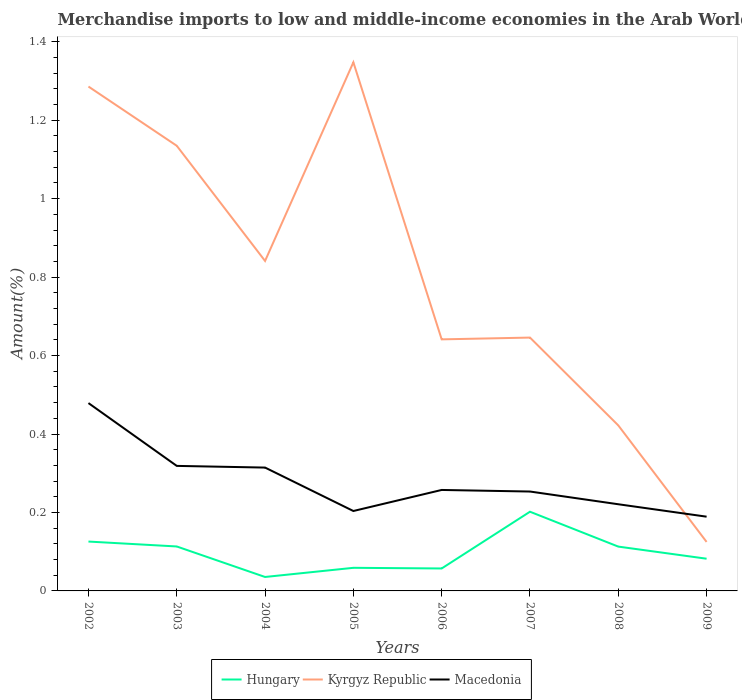How many different coloured lines are there?
Your answer should be very brief. 3. Across all years, what is the maximum percentage of amount earned from merchandise imports in Hungary?
Offer a terse response. 0.04. What is the total percentage of amount earned from merchandise imports in Hungary in the graph?
Offer a terse response. -0.02. What is the difference between the highest and the second highest percentage of amount earned from merchandise imports in Hungary?
Offer a terse response. 0.17. How many lines are there?
Your answer should be very brief. 3. What is the difference between two consecutive major ticks on the Y-axis?
Give a very brief answer. 0.2. Are the values on the major ticks of Y-axis written in scientific E-notation?
Your answer should be compact. No. How are the legend labels stacked?
Make the answer very short. Horizontal. What is the title of the graph?
Your answer should be compact. Merchandise imports to low and middle-income economies in the Arab World. Does "Belize" appear as one of the legend labels in the graph?
Your response must be concise. No. What is the label or title of the Y-axis?
Make the answer very short. Amount(%). What is the Amount(%) of Hungary in 2002?
Provide a succinct answer. 0.13. What is the Amount(%) in Kyrgyz Republic in 2002?
Your answer should be compact. 1.29. What is the Amount(%) of Macedonia in 2002?
Your response must be concise. 0.48. What is the Amount(%) of Hungary in 2003?
Give a very brief answer. 0.11. What is the Amount(%) in Kyrgyz Republic in 2003?
Your answer should be compact. 1.13. What is the Amount(%) of Macedonia in 2003?
Give a very brief answer. 0.32. What is the Amount(%) in Hungary in 2004?
Make the answer very short. 0.04. What is the Amount(%) in Kyrgyz Republic in 2004?
Provide a short and direct response. 0.84. What is the Amount(%) of Macedonia in 2004?
Your answer should be compact. 0.31. What is the Amount(%) in Hungary in 2005?
Your answer should be compact. 0.06. What is the Amount(%) of Kyrgyz Republic in 2005?
Provide a succinct answer. 1.35. What is the Amount(%) in Macedonia in 2005?
Provide a succinct answer. 0.2. What is the Amount(%) of Hungary in 2006?
Your response must be concise. 0.06. What is the Amount(%) in Kyrgyz Republic in 2006?
Your answer should be compact. 0.64. What is the Amount(%) in Macedonia in 2006?
Your answer should be very brief. 0.26. What is the Amount(%) in Hungary in 2007?
Your answer should be very brief. 0.2. What is the Amount(%) in Kyrgyz Republic in 2007?
Make the answer very short. 0.65. What is the Amount(%) in Macedonia in 2007?
Make the answer very short. 0.25. What is the Amount(%) in Hungary in 2008?
Your response must be concise. 0.11. What is the Amount(%) in Kyrgyz Republic in 2008?
Your response must be concise. 0.42. What is the Amount(%) of Macedonia in 2008?
Provide a succinct answer. 0.22. What is the Amount(%) in Hungary in 2009?
Your response must be concise. 0.08. What is the Amount(%) of Kyrgyz Republic in 2009?
Offer a very short reply. 0.12. What is the Amount(%) in Macedonia in 2009?
Offer a terse response. 0.19. Across all years, what is the maximum Amount(%) in Hungary?
Give a very brief answer. 0.2. Across all years, what is the maximum Amount(%) in Kyrgyz Republic?
Make the answer very short. 1.35. Across all years, what is the maximum Amount(%) in Macedonia?
Provide a succinct answer. 0.48. Across all years, what is the minimum Amount(%) in Hungary?
Offer a terse response. 0.04. Across all years, what is the minimum Amount(%) in Kyrgyz Republic?
Provide a succinct answer. 0.12. Across all years, what is the minimum Amount(%) in Macedonia?
Offer a terse response. 0.19. What is the total Amount(%) of Hungary in the graph?
Give a very brief answer. 0.79. What is the total Amount(%) of Kyrgyz Republic in the graph?
Keep it short and to the point. 6.44. What is the total Amount(%) in Macedonia in the graph?
Your answer should be very brief. 2.24. What is the difference between the Amount(%) of Hungary in 2002 and that in 2003?
Your response must be concise. 0.01. What is the difference between the Amount(%) of Kyrgyz Republic in 2002 and that in 2003?
Give a very brief answer. 0.15. What is the difference between the Amount(%) of Macedonia in 2002 and that in 2003?
Your answer should be compact. 0.16. What is the difference between the Amount(%) of Hungary in 2002 and that in 2004?
Provide a short and direct response. 0.09. What is the difference between the Amount(%) of Kyrgyz Republic in 2002 and that in 2004?
Ensure brevity in your answer.  0.44. What is the difference between the Amount(%) of Macedonia in 2002 and that in 2004?
Offer a terse response. 0.16. What is the difference between the Amount(%) of Hungary in 2002 and that in 2005?
Give a very brief answer. 0.07. What is the difference between the Amount(%) of Kyrgyz Republic in 2002 and that in 2005?
Ensure brevity in your answer.  -0.06. What is the difference between the Amount(%) in Macedonia in 2002 and that in 2005?
Give a very brief answer. 0.28. What is the difference between the Amount(%) in Hungary in 2002 and that in 2006?
Your answer should be compact. 0.07. What is the difference between the Amount(%) of Kyrgyz Republic in 2002 and that in 2006?
Provide a succinct answer. 0.64. What is the difference between the Amount(%) in Macedonia in 2002 and that in 2006?
Give a very brief answer. 0.22. What is the difference between the Amount(%) in Hungary in 2002 and that in 2007?
Your response must be concise. -0.08. What is the difference between the Amount(%) in Kyrgyz Republic in 2002 and that in 2007?
Offer a terse response. 0.64. What is the difference between the Amount(%) in Macedonia in 2002 and that in 2007?
Make the answer very short. 0.23. What is the difference between the Amount(%) of Hungary in 2002 and that in 2008?
Provide a short and direct response. 0.01. What is the difference between the Amount(%) in Kyrgyz Republic in 2002 and that in 2008?
Your answer should be very brief. 0.86. What is the difference between the Amount(%) in Macedonia in 2002 and that in 2008?
Keep it short and to the point. 0.26. What is the difference between the Amount(%) of Hungary in 2002 and that in 2009?
Keep it short and to the point. 0.04. What is the difference between the Amount(%) in Kyrgyz Republic in 2002 and that in 2009?
Your answer should be compact. 1.16. What is the difference between the Amount(%) in Macedonia in 2002 and that in 2009?
Ensure brevity in your answer.  0.29. What is the difference between the Amount(%) in Hungary in 2003 and that in 2004?
Offer a very short reply. 0.08. What is the difference between the Amount(%) in Kyrgyz Republic in 2003 and that in 2004?
Offer a terse response. 0.29. What is the difference between the Amount(%) of Macedonia in 2003 and that in 2004?
Offer a very short reply. 0. What is the difference between the Amount(%) in Hungary in 2003 and that in 2005?
Keep it short and to the point. 0.05. What is the difference between the Amount(%) in Kyrgyz Republic in 2003 and that in 2005?
Ensure brevity in your answer.  -0.21. What is the difference between the Amount(%) in Macedonia in 2003 and that in 2005?
Give a very brief answer. 0.12. What is the difference between the Amount(%) of Hungary in 2003 and that in 2006?
Give a very brief answer. 0.06. What is the difference between the Amount(%) in Kyrgyz Republic in 2003 and that in 2006?
Give a very brief answer. 0.49. What is the difference between the Amount(%) of Macedonia in 2003 and that in 2006?
Your answer should be compact. 0.06. What is the difference between the Amount(%) of Hungary in 2003 and that in 2007?
Your response must be concise. -0.09. What is the difference between the Amount(%) of Kyrgyz Republic in 2003 and that in 2007?
Offer a terse response. 0.49. What is the difference between the Amount(%) in Macedonia in 2003 and that in 2007?
Keep it short and to the point. 0.07. What is the difference between the Amount(%) in Kyrgyz Republic in 2003 and that in 2008?
Offer a very short reply. 0.71. What is the difference between the Amount(%) of Macedonia in 2003 and that in 2008?
Give a very brief answer. 0.1. What is the difference between the Amount(%) of Hungary in 2003 and that in 2009?
Provide a succinct answer. 0.03. What is the difference between the Amount(%) in Kyrgyz Republic in 2003 and that in 2009?
Provide a succinct answer. 1.01. What is the difference between the Amount(%) of Macedonia in 2003 and that in 2009?
Give a very brief answer. 0.13. What is the difference between the Amount(%) in Hungary in 2004 and that in 2005?
Keep it short and to the point. -0.02. What is the difference between the Amount(%) in Kyrgyz Republic in 2004 and that in 2005?
Keep it short and to the point. -0.51. What is the difference between the Amount(%) in Macedonia in 2004 and that in 2005?
Give a very brief answer. 0.11. What is the difference between the Amount(%) in Hungary in 2004 and that in 2006?
Your response must be concise. -0.02. What is the difference between the Amount(%) in Kyrgyz Republic in 2004 and that in 2006?
Your answer should be compact. 0.2. What is the difference between the Amount(%) of Macedonia in 2004 and that in 2006?
Keep it short and to the point. 0.06. What is the difference between the Amount(%) in Hungary in 2004 and that in 2007?
Offer a terse response. -0.17. What is the difference between the Amount(%) of Kyrgyz Republic in 2004 and that in 2007?
Your answer should be very brief. 0.2. What is the difference between the Amount(%) of Macedonia in 2004 and that in 2007?
Give a very brief answer. 0.06. What is the difference between the Amount(%) in Hungary in 2004 and that in 2008?
Provide a short and direct response. -0.08. What is the difference between the Amount(%) in Kyrgyz Republic in 2004 and that in 2008?
Your response must be concise. 0.42. What is the difference between the Amount(%) in Macedonia in 2004 and that in 2008?
Your answer should be compact. 0.09. What is the difference between the Amount(%) of Hungary in 2004 and that in 2009?
Give a very brief answer. -0.05. What is the difference between the Amount(%) in Kyrgyz Republic in 2004 and that in 2009?
Your answer should be compact. 0.72. What is the difference between the Amount(%) of Macedonia in 2004 and that in 2009?
Your answer should be very brief. 0.13. What is the difference between the Amount(%) in Hungary in 2005 and that in 2006?
Your answer should be very brief. 0. What is the difference between the Amount(%) in Kyrgyz Republic in 2005 and that in 2006?
Make the answer very short. 0.71. What is the difference between the Amount(%) of Macedonia in 2005 and that in 2006?
Offer a terse response. -0.05. What is the difference between the Amount(%) in Hungary in 2005 and that in 2007?
Offer a terse response. -0.14. What is the difference between the Amount(%) in Kyrgyz Republic in 2005 and that in 2007?
Make the answer very short. 0.7. What is the difference between the Amount(%) in Macedonia in 2005 and that in 2007?
Your response must be concise. -0.05. What is the difference between the Amount(%) in Hungary in 2005 and that in 2008?
Your response must be concise. -0.05. What is the difference between the Amount(%) in Kyrgyz Republic in 2005 and that in 2008?
Your answer should be very brief. 0.93. What is the difference between the Amount(%) of Macedonia in 2005 and that in 2008?
Ensure brevity in your answer.  -0.02. What is the difference between the Amount(%) of Hungary in 2005 and that in 2009?
Offer a very short reply. -0.02. What is the difference between the Amount(%) of Kyrgyz Republic in 2005 and that in 2009?
Your response must be concise. 1.22. What is the difference between the Amount(%) of Macedonia in 2005 and that in 2009?
Ensure brevity in your answer.  0.01. What is the difference between the Amount(%) of Hungary in 2006 and that in 2007?
Give a very brief answer. -0.14. What is the difference between the Amount(%) in Kyrgyz Republic in 2006 and that in 2007?
Your response must be concise. -0. What is the difference between the Amount(%) of Macedonia in 2006 and that in 2007?
Your response must be concise. 0. What is the difference between the Amount(%) in Hungary in 2006 and that in 2008?
Offer a very short reply. -0.06. What is the difference between the Amount(%) in Kyrgyz Republic in 2006 and that in 2008?
Offer a terse response. 0.22. What is the difference between the Amount(%) of Macedonia in 2006 and that in 2008?
Your answer should be very brief. 0.04. What is the difference between the Amount(%) in Hungary in 2006 and that in 2009?
Your answer should be very brief. -0.02. What is the difference between the Amount(%) of Kyrgyz Republic in 2006 and that in 2009?
Make the answer very short. 0.52. What is the difference between the Amount(%) in Macedonia in 2006 and that in 2009?
Make the answer very short. 0.07. What is the difference between the Amount(%) in Hungary in 2007 and that in 2008?
Ensure brevity in your answer.  0.09. What is the difference between the Amount(%) in Kyrgyz Republic in 2007 and that in 2008?
Make the answer very short. 0.22. What is the difference between the Amount(%) in Macedonia in 2007 and that in 2008?
Give a very brief answer. 0.03. What is the difference between the Amount(%) of Hungary in 2007 and that in 2009?
Give a very brief answer. 0.12. What is the difference between the Amount(%) in Kyrgyz Republic in 2007 and that in 2009?
Your response must be concise. 0.52. What is the difference between the Amount(%) in Macedonia in 2007 and that in 2009?
Your answer should be very brief. 0.06. What is the difference between the Amount(%) of Hungary in 2008 and that in 2009?
Provide a short and direct response. 0.03. What is the difference between the Amount(%) in Kyrgyz Republic in 2008 and that in 2009?
Make the answer very short. 0.3. What is the difference between the Amount(%) in Macedonia in 2008 and that in 2009?
Your response must be concise. 0.03. What is the difference between the Amount(%) of Hungary in 2002 and the Amount(%) of Kyrgyz Republic in 2003?
Your response must be concise. -1.01. What is the difference between the Amount(%) in Hungary in 2002 and the Amount(%) in Macedonia in 2003?
Make the answer very short. -0.19. What is the difference between the Amount(%) in Kyrgyz Republic in 2002 and the Amount(%) in Macedonia in 2003?
Give a very brief answer. 0.97. What is the difference between the Amount(%) in Hungary in 2002 and the Amount(%) in Kyrgyz Republic in 2004?
Keep it short and to the point. -0.72. What is the difference between the Amount(%) in Hungary in 2002 and the Amount(%) in Macedonia in 2004?
Make the answer very short. -0.19. What is the difference between the Amount(%) in Kyrgyz Republic in 2002 and the Amount(%) in Macedonia in 2004?
Give a very brief answer. 0.97. What is the difference between the Amount(%) in Hungary in 2002 and the Amount(%) in Kyrgyz Republic in 2005?
Ensure brevity in your answer.  -1.22. What is the difference between the Amount(%) of Hungary in 2002 and the Amount(%) of Macedonia in 2005?
Your answer should be compact. -0.08. What is the difference between the Amount(%) in Kyrgyz Republic in 2002 and the Amount(%) in Macedonia in 2005?
Give a very brief answer. 1.08. What is the difference between the Amount(%) in Hungary in 2002 and the Amount(%) in Kyrgyz Republic in 2006?
Your answer should be compact. -0.52. What is the difference between the Amount(%) of Hungary in 2002 and the Amount(%) of Macedonia in 2006?
Your answer should be compact. -0.13. What is the difference between the Amount(%) in Kyrgyz Republic in 2002 and the Amount(%) in Macedonia in 2006?
Offer a terse response. 1.03. What is the difference between the Amount(%) in Hungary in 2002 and the Amount(%) in Kyrgyz Republic in 2007?
Offer a terse response. -0.52. What is the difference between the Amount(%) in Hungary in 2002 and the Amount(%) in Macedonia in 2007?
Your answer should be compact. -0.13. What is the difference between the Amount(%) of Kyrgyz Republic in 2002 and the Amount(%) of Macedonia in 2007?
Give a very brief answer. 1.03. What is the difference between the Amount(%) in Hungary in 2002 and the Amount(%) in Kyrgyz Republic in 2008?
Your response must be concise. -0.3. What is the difference between the Amount(%) of Hungary in 2002 and the Amount(%) of Macedonia in 2008?
Ensure brevity in your answer.  -0.1. What is the difference between the Amount(%) in Kyrgyz Republic in 2002 and the Amount(%) in Macedonia in 2008?
Your answer should be very brief. 1.06. What is the difference between the Amount(%) of Hungary in 2002 and the Amount(%) of Kyrgyz Republic in 2009?
Offer a very short reply. 0. What is the difference between the Amount(%) of Hungary in 2002 and the Amount(%) of Macedonia in 2009?
Offer a terse response. -0.06. What is the difference between the Amount(%) of Kyrgyz Republic in 2002 and the Amount(%) of Macedonia in 2009?
Keep it short and to the point. 1.1. What is the difference between the Amount(%) in Hungary in 2003 and the Amount(%) in Kyrgyz Republic in 2004?
Offer a terse response. -0.73. What is the difference between the Amount(%) of Hungary in 2003 and the Amount(%) of Macedonia in 2004?
Your answer should be compact. -0.2. What is the difference between the Amount(%) in Kyrgyz Republic in 2003 and the Amount(%) in Macedonia in 2004?
Provide a short and direct response. 0.82. What is the difference between the Amount(%) of Hungary in 2003 and the Amount(%) of Kyrgyz Republic in 2005?
Give a very brief answer. -1.23. What is the difference between the Amount(%) of Hungary in 2003 and the Amount(%) of Macedonia in 2005?
Give a very brief answer. -0.09. What is the difference between the Amount(%) of Kyrgyz Republic in 2003 and the Amount(%) of Macedonia in 2005?
Keep it short and to the point. 0.93. What is the difference between the Amount(%) in Hungary in 2003 and the Amount(%) in Kyrgyz Republic in 2006?
Keep it short and to the point. -0.53. What is the difference between the Amount(%) of Hungary in 2003 and the Amount(%) of Macedonia in 2006?
Ensure brevity in your answer.  -0.14. What is the difference between the Amount(%) of Kyrgyz Republic in 2003 and the Amount(%) of Macedonia in 2006?
Provide a short and direct response. 0.88. What is the difference between the Amount(%) in Hungary in 2003 and the Amount(%) in Kyrgyz Republic in 2007?
Offer a very short reply. -0.53. What is the difference between the Amount(%) in Hungary in 2003 and the Amount(%) in Macedonia in 2007?
Keep it short and to the point. -0.14. What is the difference between the Amount(%) of Kyrgyz Republic in 2003 and the Amount(%) of Macedonia in 2007?
Give a very brief answer. 0.88. What is the difference between the Amount(%) of Hungary in 2003 and the Amount(%) of Kyrgyz Republic in 2008?
Provide a short and direct response. -0.31. What is the difference between the Amount(%) of Hungary in 2003 and the Amount(%) of Macedonia in 2008?
Your response must be concise. -0.11. What is the difference between the Amount(%) of Kyrgyz Republic in 2003 and the Amount(%) of Macedonia in 2008?
Provide a short and direct response. 0.91. What is the difference between the Amount(%) of Hungary in 2003 and the Amount(%) of Kyrgyz Republic in 2009?
Keep it short and to the point. -0.01. What is the difference between the Amount(%) in Hungary in 2003 and the Amount(%) in Macedonia in 2009?
Offer a very short reply. -0.08. What is the difference between the Amount(%) in Kyrgyz Republic in 2003 and the Amount(%) in Macedonia in 2009?
Make the answer very short. 0.95. What is the difference between the Amount(%) of Hungary in 2004 and the Amount(%) of Kyrgyz Republic in 2005?
Your answer should be compact. -1.31. What is the difference between the Amount(%) of Hungary in 2004 and the Amount(%) of Macedonia in 2005?
Your answer should be compact. -0.17. What is the difference between the Amount(%) of Kyrgyz Republic in 2004 and the Amount(%) of Macedonia in 2005?
Give a very brief answer. 0.64. What is the difference between the Amount(%) of Hungary in 2004 and the Amount(%) of Kyrgyz Republic in 2006?
Give a very brief answer. -0.61. What is the difference between the Amount(%) in Hungary in 2004 and the Amount(%) in Macedonia in 2006?
Offer a terse response. -0.22. What is the difference between the Amount(%) of Kyrgyz Republic in 2004 and the Amount(%) of Macedonia in 2006?
Keep it short and to the point. 0.58. What is the difference between the Amount(%) in Hungary in 2004 and the Amount(%) in Kyrgyz Republic in 2007?
Your response must be concise. -0.61. What is the difference between the Amount(%) in Hungary in 2004 and the Amount(%) in Macedonia in 2007?
Offer a very short reply. -0.22. What is the difference between the Amount(%) of Kyrgyz Republic in 2004 and the Amount(%) of Macedonia in 2007?
Offer a terse response. 0.59. What is the difference between the Amount(%) of Hungary in 2004 and the Amount(%) of Kyrgyz Republic in 2008?
Your answer should be very brief. -0.39. What is the difference between the Amount(%) of Hungary in 2004 and the Amount(%) of Macedonia in 2008?
Provide a succinct answer. -0.19. What is the difference between the Amount(%) of Kyrgyz Republic in 2004 and the Amount(%) of Macedonia in 2008?
Ensure brevity in your answer.  0.62. What is the difference between the Amount(%) in Hungary in 2004 and the Amount(%) in Kyrgyz Republic in 2009?
Provide a succinct answer. -0.09. What is the difference between the Amount(%) in Hungary in 2004 and the Amount(%) in Macedonia in 2009?
Make the answer very short. -0.15. What is the difference between the Amount(%) of Kyrgyz Republic in 2004 and the Amount(%) of Macedonia in 2009?
Give a very brief answer. 0.65. What is the difference between the Amount(%) in Hungary in 2005 and the Amount(%) in Kyrgyz Republic in 2006?
Offer a very short reply. -0.58. What is the difference between the Amount(%) of Hungary in 2005 and the Amount(%) of Macedonia in 2006?
Offer a terse response. -0.2. What is the difference between the Amount(%) in Kyrgyz Republic in 2005 and the Amount(%) in Macedonia in 2006?
Offer a very short reply. 1.09. What is the difference between the Amount(%) of Hungary in 2005 and the Amount(%) of Kyrgyz Republic in 2007?
Offer a terse response. -0.59. What is the difference between the Amount(%) of Hungary in 2005 and the Amount(%) of Macedonia in 2007?
Offer a very short reply. -0.19. What is the difference between the Amount(%) in Kyrgyz Republic in 2005 and the Amount(%) in Macedonia in 2007?
Your response must be concise. 1.09. What is the difference between the Amount(%) in Hungary in 2005 and the Amount(%) in Kyrgyz Republic in 2008?
Keep it short and to the point. -0.36. What is the difference between the Amount(%) of Hungary in 2005 and the Amount(%) of Macedonia in 2008?
Keep it short and to the point. -0.16. What is the difference between the Amount(%) of Kyrgyz Republic in 2005 and the Amount(%) of Macedonia in 2008?
Provide a succinct answer. 1.13. What is the difference between the Amount(%) of Hungary in 2005 and the Amount(%) of Kyrgyz Republic in 2009?
Give a very brief answer. -0.07. What is the difference between the Amount(%) in Hungary in 2005 and the Amount(%) in Macedonia in 2009?
Provide a succinct answer. -0.13. What is the difference between the Amount(%) in Kyrgyz Republic in 2005 and the Amount(%) in Macedonia in 2009?
Provide a succinct answer. 1.16. What is the difference between the Amount(%) of Hungary in 2006 and the Amount(%) of Kyrgyz Republic in 2007?
Your answer should be compact. -0.59. What is the difference between the Amount(%) of Hungary in 2006 and the Amount(%) of Macedonia in 2007?
Ensure brevity in your answer.  -0.2. What is the difference between the Amount(%) of Kyrgyz Republic in 2006 and the Amount(%) of Macedonia in 2007?
Provide a succinct answer. 0.39. What is the difference between the Amount(%) in Hungary in 2006 and the Amount(%) in Kyrgyz Republic in 2008?
Ensure brevity in your answer.  -0.36. What is the difference between the Amount(%) of Hungary in 2006 and the Amount(%) of Macedonia in 2008?
Your response must be concise. -0.16. What is the difference between the Amount(%) of Kyrgyz Republic in 2006 and the Amount(%) of Macedonia in 2008?
Provide a succinct answer. 0.42. What is the difference between the Amount(%) of Hungary in 2006 and the Amount(%) of Kyrgyz Republic in 2009?
Offer a very short reply. -0.07. What is the difference between the Amount(%) of Hungary in 2006 and the Amount(%) of Macedonia in 2009?
Your answer should be compact. -0.13. What is the difference between the Amount(%) of Kyrgyz Republic in 2006 and the Amount(%) of Macedonia in 2009?
Give a very brief answer. 0.45. What is the difference between the Amount(%) in Hungary in 2007 and the Amount(%) in Kyrgyz Republic in 2008?
Ensure brevity in your answer.  -0.22. What is the difference between the Amount(%) in Hungary in 2007 and the Amount(%) in Macedonia in 2008?
Your answer should be compact. -0.02. What is the difference between the Amount(%) in Kyrgyz Republic in 2007 and the Amount(%) in Macedonia in 2008?
Make the answer very short. 0.42. What is the difference between the Amount(%) of Hungary in 2007 and the Amount(%) of Kyrgyz Republic in 2009?
Give a very brief answer. 0.08. What is the difference between the Amount(%) in Hungary in 2007 and the Amount(%) in Macedonia in 2009?
Provide a short and direct response. 0.01. What is the difference between the Amount(%) in Kyrgyz Republic in 2007 and the Amount(%) in Macedonia in 2009?
Make the answer very short. 0.46. What is the difference between the Amount(%) of Hungary in 2008 and the Amount(%) of Kyrgyz Republic in 2009?
Provide a succinct answer. -0.01. What is the difference between the Amount(%) in Hungary in 2008 and the Amount(%) in Macedonia in 2009?
Provide a succinct answer. -0.08. What is the difference between the Amount(%) of Kyrgyz Republic in 2008 and the Amount(%) of Macedonia in 2009?
Give a very brief answer. 0.23. What is the average Amount(%) in Hungary per year?
Your response must be concise. 0.1. What is the average Amount(%) in Kyrgyz Republic per year?
Offer a very short reply. 0.81. What is the average Amount(%) in Macedonia per year?
Provide a succinct answer. 0.28. In the year 2002, what is the difference between the Amount(%) of Hungary and Amount(%) of Kyrgyz Republic?
Give a very brief answer. -1.16. In the year 2002, what is the difference between the Amount(%) in Hungary and Amount(%) in Macedonia?
Make the answer very short. -0.35. In the year 2002, what is the difference between the Amount(%) in Kyrgyz Republic and Amount(%) in Macedonia?
Your response must be concise. 0.81. In the year 2003, what is the difference between the Amount(%) of Hungary and Amount(%) of Kyrgyz Republic?
Give a very brief answer. -1.02. In the year 2003, what is the difference between the Amount(%) in Hungary and Amount(%) in Macedonia?
Your response must be concise. -0.21. In the year 2003, what is the difference between the Amount(%) of Kyrgyz Republic and Amount(%) of Macedonia?
Offer a terse response. 0.82. In the year 2004, what is the difference between the Amount(%) in Hungary and Amount(%) in Kyrgyz Republic?
Make the answer very short. -0.81. In the year 2004, what is the difference between the Amount(%) of Hungary and Amount(%) of Macedonia?
Keep it short and to the point. -0.28. In the year 2004, what is the difference between the Amount(%) in Kyrgyz Republic and Amount(%) in Macedonia?
Give a very brief answer. 0.53. In the year 2005, what is the difference between the Amount(%) in Hungary and Amount(%) in Kyrgyz Republic?
Offer a very short reply. -1.29. In the year 2005, what is the difference between the Amount(%) of Hungary and Amount(%) of Macedonia?
Make the answer very short. -0.14. In the year 2005, what is the difference between the Amount(%) of Kyrgyz Republic and Amount(%) of Macedonia?
Your response must be concise. 1.14. In the year 2006, what is the difference between the Amount(%) of Hungary and Amount(%) of Kyrgyz Republic?
Give a very brief answer. -0.58. In the year 2006, what is the difference between the Amount(%) in Hungary and Amount(%) in Macedonia?
Give a very brief answer. -0.2. In the year 2006, what is the difference between the Amount(%) in Kyrgyz Republic and Amount(%) in Macedonia?
Keep it short and to the point. 0.38. In the year 2007, what is the difference between the Amount(%) of Hungary and Amount(%) of Kyrgyz Republic?
Give a very brief answer. -0.44. In the year 2007, what is the difference between the Amount(%) in Hungary and Amount(%) in Macedonia?
Your response must be concise. -0.05. In the year 2007, what is the difference between the Amount(%) of Kyrgyz Republic and Amount(%) of Macedonia?
Offer a terse response. 0.39. In the year 2008, what is the difference between the Amount(%) of Hungary and Amount(%) of Kyrgyz Republic?
Your response must be concise. -0.31. In the year 2008, what is the difference between the Amount(%) of Hungary and Amount(%) of Macedonia?
Ensure brevity in your answer.  -0.11. In the year 2008, what is the difference between the Amount(%) of Kyrgyz Republic and Amount(%) of Macedonia?
Offer a very short reply. 0.2. In the year 2009, what is the difference between the Amount(%) of Hungary and Amount(%) of Kyrgyz Republic?
Offer a very short reply. -0.04. In the year 2009, what is the difference between the Amount(%) of Hungary and Amount(%) of Macedonia?
Your answer should be very brief. -0.11. In the year 2009, what is the difference between the Amount(%) of Kyrgyz Republic and Amount(%) of Macedonia?
Your response must be concise. -0.06. What is the ratio of the Amount(%) in Hungary in 2002 to that in 2003?
Keep it short and to the point. 1.11. What is the ratio of the Amount(%) of Kyrgyz Republic in 2002 to that in 2003?
Give a very brief answer. 1.13. What is the ratio of the Amount(%) in Macedonia in 2002 to that in 2003?
Make the answer very short. 1.5. What is the ratio of the Amount(%) of Hungary in 2002 to that in 2004?
Your answer should be compact. 3.54. What is the ratio of the Amount(%) of Kyrgyz Republic in 2002 to that in 2004?
Your response must be concise. 1.53. What is the ratio of the Amount(%) in Macedonia in 2002 to that in 2004?
Your answer should be compact. 1.52. What is the ratio of the Amount(%) of Hungary in 2002 to that in 2005?
Your answer should be compact. 2.14. What is the ratio of the Amount(%) in Kyrgyz Republic in 2002 to that in 2005?
Provide a short and direct response. 0.95. What is the ratio of the Amount(%) in Macedonia in 2002 to that in 2005?
Your answer should be compact. 2.35. What is the ratio of the Amount(%) in Hungary in 2002 to that in 2006?
Provide a short and direct response. 2.2. What is the ratio of the Amount(%) of Kyrgyz Republic in 2002 to that in 2006?
Offer a terse response. 2. What is the ratio of the Amount(%) in Macedonia in 2002 to that in 2006?
Keep it short and to the point. 1.86. What is the ratio of the Amount(%) of Hungary in 2002 to that in 2007?
Give a very brief answer. 0.62. What is the ratio of the Amount(%) of Kyrgyz Republic in 2002 to that in 2007?
Give a very brief answer. 1.99. What is the ratio of the Amount(%) of Macedonia in 2002 to that in 2007?
Your answer should be compact. 1.89. What is the ratio of the Amount(%) of Hungary in 2002 to that in 2008?
Make the answer very short. 1.11. What is the ratio of the Amount(%) of Kyrgyz Republic in 2002 to that in 2008?
Provide a succinct answer. 3.05. What is the ratio of the Amount(%) of Macedonia in 2002 to that in 2008?
Give a very brief answer. 2.17. What is the ratio of the Amount(%) in Hungary in 2002 to that in 2009?
Your answer should be compact. 1.53. What is the ratio of the Amount(%) in Kyrgyz Republic in 2002 to that in 2009?
Give a very brief answer. 10.29. What is the ratio of the Amount(%) of Macedonia in 2002 to that in 2009?
Your answer should be very brief. 2.53. What is the ratio of the Amount(%) of Hungary in 2003 to that in 2004?
Give a very brief answer. 3.19. What is the ratio of the Amount(%) in Kyrgyz Republic in 2003 to that in 2004?
Keep it short and to the point. 1.35. What is the ratio of the Amount(%) of Macedonia in 2003 to that in 2004?
Make the answer very short. 1.01. What is the ratio of the Amount(%) of Hungary in 2003 to that in 2005?
Make the answer very short. 1.92. What is the ratio of the Amount(%) in Kyrgyz Republic in 2003 to that in 2005?
Your answer should be compact. 0.84. What is the ratio of the Amount(%) of Macedonia in 2003 to that in 2005?
Provide a succinct answer. 1.56. What is the ratio of the Amount(%) of Hungary in 2003 to that in 2006?
Give a very brief answer. 1.98. What is the ratio of the Amount(%) of Kyrgyz Republic in 2003 to that in 2006?
Make the answer very short. 1.77. What is the ratio of the Amount(%) of Macedonia in 2003 to that in 2006?
Ensure brevity in your answer.  1.24. What is the ratio of the Amount(%) of Hungary in 2003 to that in 2007?
Offer a very short reply. 0.56. What is the ratio of the Amount(%) of Kyrgyz Republic in 2003 to that in 2007?
Your answer should be very brief. 1.76. What is the ratio of the Amount(%) of Macedonia in 2003 to that in 2007?
Your answer should be compact. 1.26. What is the ratio of the Amount(%) of Kyrgyz Republic in 2003 to that in 2008?
Offer a very short reply. 2.69. What is the ratio of the Amount(%) of Macedonia in 2003 to that in 2008?
Ensure brevity in your answer.  1.44. What is the ratio of the Amount(%) of Hungary in 2003 to that in 2009?
Give a very brief answer. 1.38. What is the ratio of the Amount(%) in Kyrgyz Republic in 2003 to that in 2009?
Your response must be concise. 9.09. What is the ratio of the Amount(%) in Macedonia in 2003 to that in 2009?
Your answer should be very brief. 1.68. What is the ratio of the Amount(%) of Hungary in 2004 to that in 2005?
Keep it short and to the point. 0.6. What is the ratio of the Amount(%) of Kyrgyz Republic in 2004 to that in 2005?
Ensure brevity in your answer.  0.62. What is the ratio of the Amount(%) in Macedonia in 2004 to that in 2005?
Provide a succinct answer. 1.54. What is the ratio of the Amount(%) in Hungary in 2004 to that in 2006?
Make the answer very short. 0.62. What is the ratio of the Amount(%) in Kyrgyz Republic in 2004 to that in 2006?
Make the answer very short. 1.31. What is the ratio of the Amount(%) of Macedonia in 2004 to that in 2006?
Provide a short and direct response. 1.22. What is the ratio of the Amount(%) in Hungary in 2004 to that in 2007?
Offer a very short reply. 0.18. What is the ratio of the Amount(%) of Kyrgyz Republic in 2004 to that in 2007?
Your answer should be compact. 1.3. What is the ratio of the Amount(%) in Macedonia in 2004 to that in 2007?
Make the answer very short. 1.24. What is the ratio of the Amount(%) in Hungary in 2004 to that in 2008?
Make the answer very short. 0.31. What is the ratio of the Amount(%) in Kyrgyz Republic in 2004 to that in 2008?
Offer a very short reply. 1.99. What is the ratio of the Amount(%) of Macedonia in 2004 to that in 2008?
Keep it short and to the point. 1.42. What is the ratio of the Amount(%) of Hungary in 2004 to that in 2009?
Keep it short and to the point. 0.43. What is the ratio of the Amount(%) in Kyrgyz Republic in 2004 to that in 2009?
Make the answer very short. 6.73. What is the ratio of the Amount(%) in Macedonia in 2004 to that in 2009?
Ensure brevity in your answer.  1.66. What is the ratio of the Amount(%) of Hungary in 2005 to that in 2006?
Provide a succinct answer. 1.03. What is the ratio of the Amount(%) in Kyrgyz Republic in 2005 to that in 2006?
Your answer should be compact. 2.1. What is the ratio of the Amount(%) in Macedonia in 2005 to that in 2006?
Keep it short and to the point. 0.79. What is the ratio of the Amount(%) of Hungary in 2005 to that in 2007?
Provide a succinct answer. 0.29. What is the ratio of the Amount(%) of Kyrgyz Republic in 2005 to that in 2007?
Provide a short and direct response. 2.09. What is the ratio of the Amount(%) of Macedonia in 2005 to that in 2007?
Offer a very short reply. 0.8. What is the ratio of the Amount(%) of Hungary in 2005 to that in 2008?
Ensure brevity in your answer.  0.52. What is the ratio of the Amount(%) of Kyrgyz Republic in 2005 to that in 2008?
Give a very brief answer. 3.19. What is the ratio of the Amount(%) in Macedonia in 2005 to that in 2008?
Provide a succinct answer. 0.92. What is the ratio of the Amount(%) of Hungary in 2005 to that in 2009?
Keep it short and to the point. 0.72. What is the ratio of the Amount(%) of Kyrgyz Republic in 2005 to that in 2009?
Provide a short and direct response. 10.79. What is the ratio of the Amount(%) of Macedonia in 2005 to that in 2009?
Offer a very short reply. 1.08. What is the ratio of the Amount(%) of Hungary in 2006 to that in 2007?
Offer a very short reply. 0.28. What is the ratio of the Amount(%) in Macedonia in 2006 to that in 2007?
Make the answer very short. 1.02. What is the ratio of the Amount(%) in Hungary in 2006 to that in 2008?
Ensure brevity in your answer.  0.51. What is the ratio of the Amount(%) in Kyrgyz Republic in 2006 to that in 2008?
Give a very brief answer. 1.52. What is the ratio of the Amount(%) of Macedonia in 2006 to that in 2008?
Ensure brevity in your answer.  1.16. What is the ratio of the Amount(%) of Hungary in 2006 to that in 2009?
Your response must be concise. 0.7. What is the ratio of the Amount(%) in Kyrgyz Republic in 2006 to that in 2009?
Keep it short and to the point. 5.13. What is the ratio of the Amount(%) in Macedonia in 2006 to that in 2009?
Offer a very short reply. 1.36. What is the ratio of the Amount(%) of Hungary in 2007 to that in 2008?
Provide a short and direct response. 1.79. What is the ratio of the Amount(%) in Kyrgyz Republic in 2007 to that in 2008?
Keep it short and to the point. 1.53. What is the ratio of the Amount(%) of Macedonia in 2007 to that in 2008?
Provide a succinct answer. 1.15. What is the ratio of the Amount(%) of Hungary in 2007 to that in 2009?
Give a very brief answer. 2.46. What is the ratio of the Amount(%) of Kyrgyz Republic in 2007 to that in 2009?
Provide a short and direct response. 5.17. What is the ratio of the Amount(%) of Macedonia in 2007 to that in 2009?
Give a very brief answer. 1.34. What is the ratio of the Amount(%) of Hungary in 2008 to that in 2009?
Offer a terse response. 1.38. What is the ratio of the Amount(%) of Kyrgyz Republic in 2008 to that in 2009?
Keep it short and to the point. 3.38. What is the ratio of the Amount(%) in Macedonia in 2008 to that in 2009?
Keep it short and to the point. 1.17. What is the difference between the highest and the second highest Amount(%) of Hungary?
Keep it short and to the point. 0.08. What is the difference between the highest and the second highest Amount(%) in Kyrgyz Republic?
Ensure brevity in your answer.  0.06. What is the difference between the highest and the second highest Amount(%) in Macedonia?
Ensure brevity in your answer.  0.16. What is the difference between the highest and the lowest Amount(%) in Hungary?
Offer a terse response. 0.17. What is the difference between the highest and the lowest Amount(%) in Kyrgyz Republic?
Your answer should be compact. 1.22. What is the difference between the highest and the lowest Amount(%) of Macedonia?
Keep it short and to the point. 0.29. 